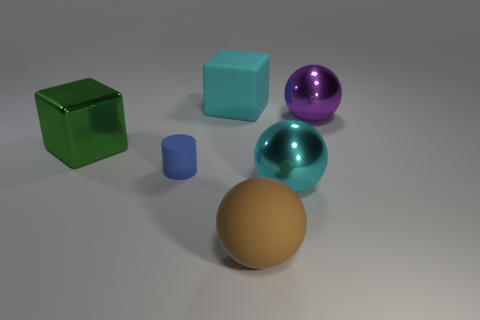What shape is the big object that is the same color as the matte cube?
Offer a very short reply. Sphere. What is the size of the metal ball that is the same color as the rubber cube?
Provide a succinct answer. Large. What number of things are either metallic balls behind the big metallic cube or big metal spheres that are behind the big green metallic block?
Your answer should be very brief. 1. There is a cyan rubber object; is it the same shape as the large matte object that is in front of the big green thing?
Your answer should be very brief. No. How many other things are the same shape as the large green shiny thing?
Your response must be concise. 1. What number of objects are big shiny balls or large cyan shiny spheres?
Provide a short and direct response. 2. Does the tiny rubber thing have the same color as the metal cube?
Your answer should be very brief. No. Is there any other thing that has the same size as the cyan metal thing?
Ensure brevity in your answer.  Yes. What is the shape of the big rubber object that is in front of the big metal thing that is in front of the big metal block?
Ensure brevity in your answer.  Sphere. Are there fewer large purple rubber cubes than large purple balls?
Ensure brevity in your answer.  Yes. 